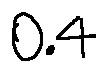<formula> <loc_0><loc_0><loc_500><loc_500>0 . 4</formula> 